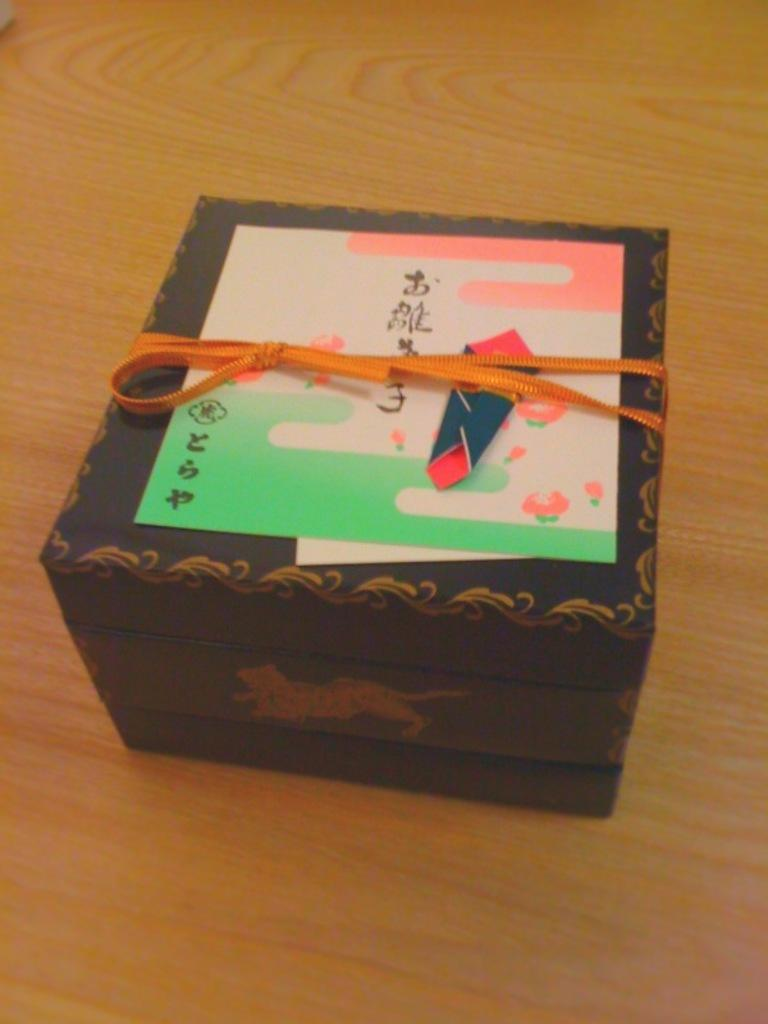<image>
Present a compact description of the photo's key features. A small box with a note in foreign characters on it. 